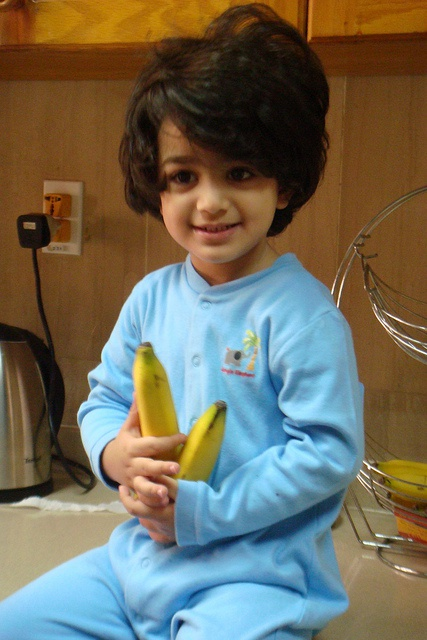Describe the objects in this image and their specific colors. I can see people in maroon, lightblue, black, and gray tones, banana in maroon, olive, and gold tones, banana in maroon, olive, and gray tones, banana in maroon, olive, and gray tones, and banana in maroon, olive, and black tones in this image. 